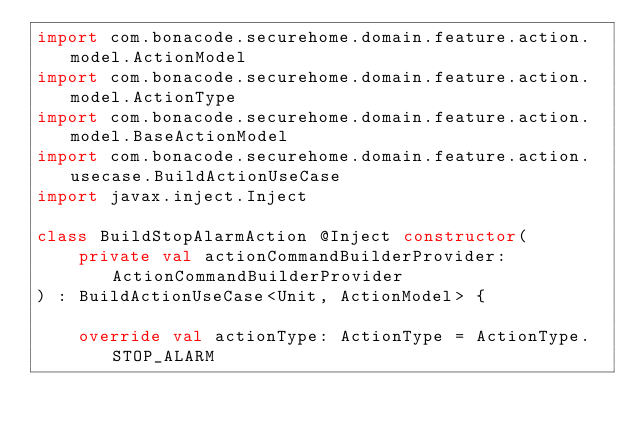Convert code to text. <code><loc_0><loc_0><loc_500><loc_500><_Kotlin_>import com.bonacode.securehome.domain.feature.action.model.ActionModel
import com.bonacode.securehome.domain.feature.action.model.ActionType
import com.bonacode.securehome.domain.feature.action.model.BaseActionModel
import com.bonacode.securehome.domain.feature.action.usecase.BuildActionUseCase
import javax.inject.Inject

class BuildStopAlarmAction @Inject constructor(
    private val actionCommandBuilderProvider: ActionCommandBuilderProvider
) : BuildActionUseCase<Unit, ActionModel> {

    override val actionType: ActionType = ActionType.STOP_ALARM
</code> 